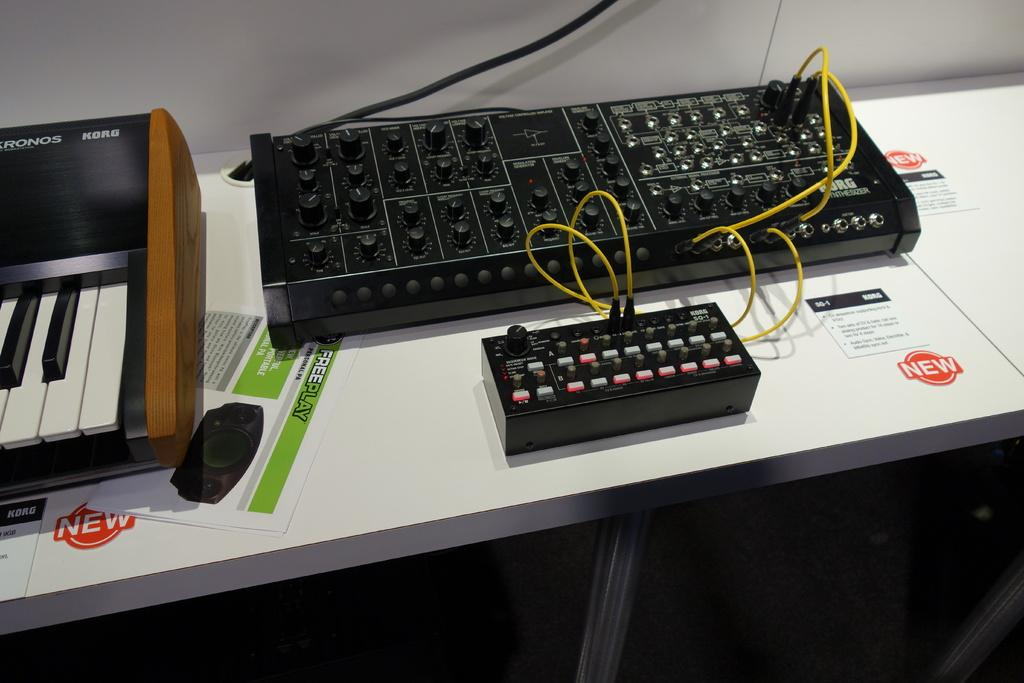What type of furniture is present in the image? There is a table in the image. What electronic device is on the table? There is a Casio on the table. What else can be seen on the table besides the Casio? There is a paper and an electronic instrument on the table. Reasoning: Let's let's think step by step in order to produce the conversation. We start by identifying the main subject in the image, which is the table. Then, we expand the conversation to include other items that are also visible on the table, such as the Casio, paper, and electronic instrument. Each question is designed to elicit a specific detail about the image that is known from the provided facts. Absurd Question/Answer: What type of team is visible in the image? There is no team present in the image. 